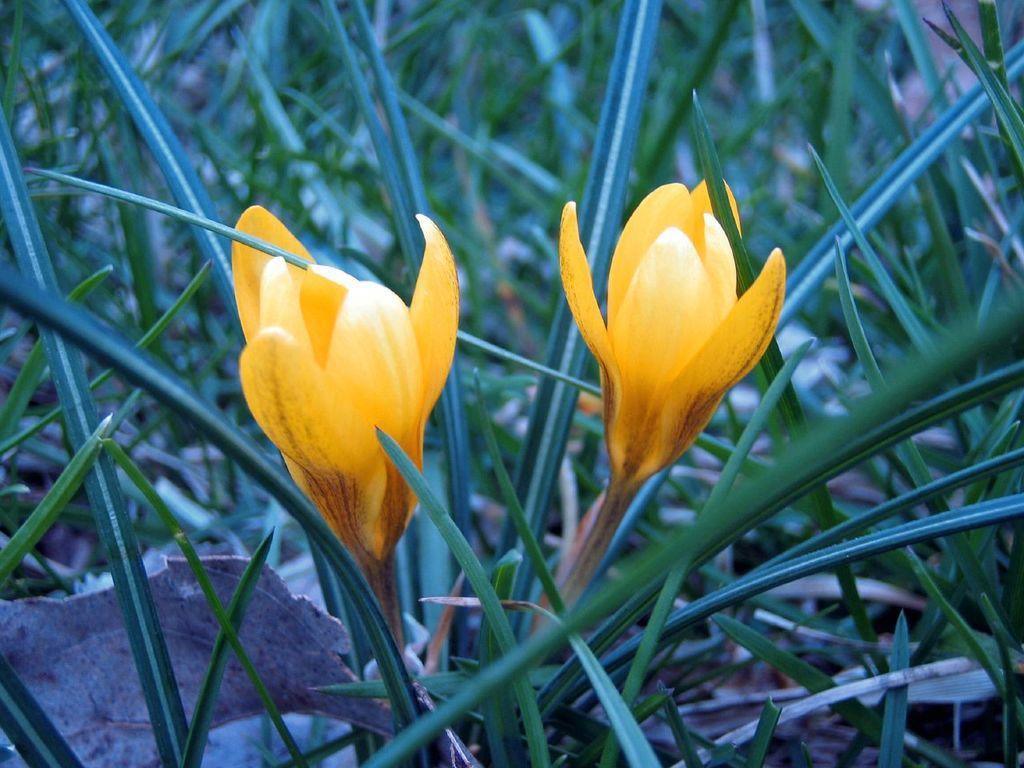How would you summarize this image in a sentence or two? In this image we can able to see some plants, and there are two flowers which are of yellow in color. 